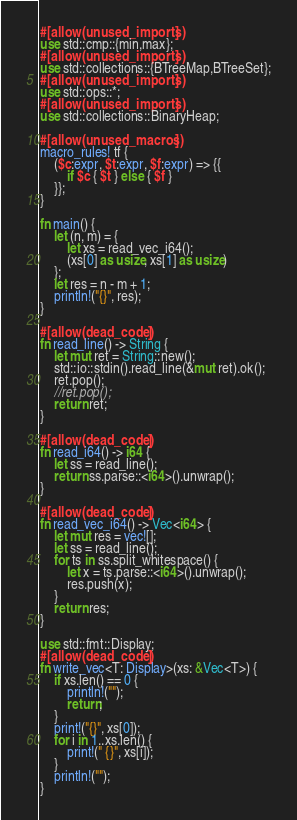<code> <loc_0><loc_0><loc_500><loc_500><_Rust_>#[allow(unused_imports)]
use std::cmp::{min,max};
#[allow(unused_imports)]
use std::collections::{BTreeMap,BTreeSet};
#[allow(unused_imports)]
use std::ops::*;
#[allow(unused_imports)]
use std::collections::BinaryHeap;

#[allow(unused_macros)]
macro_rules! tf {
    ($c:expr, $t:expr, $f:expr) => {{
        if $c { $t } else { $f }
    }};
}

fn main() {
    let (n, m) = {
        let xs = read_vec_i64();
        (xs[0] as usize, xs[1] as usize)
    };
    let res = n - m + 1;
    println!("{}", res);
}

#[allow(dead_code)]
fn read_line() -> String {
    let mut ret = String::new();
    std::io::stdin().read_line(&mut ret).ok();
    ret.pop();
    //ret.pop();
    return ret;
}

#[allow(dead_code)]
fn read_i64() -> i64 {
    let ss = read_line();
    return ss.parse::<i64>().unwrap();
}

#[allow(dead_code)]
fn read_vec_i64() -> Vec<i64> {
    let mut res = vec![];
    let ss = read_line();
    for ts in ss.split_whitespace() {
        let x = ts.parse::<i64>().unwrap();
        res.push(x);
    }
    return res;
}

use std::fmt::Display;
#[allow(dead_code)]
fn write_vec<T: Display>(xs: &Vec<T>) {
    if xs.len() == 0 {
        println!("");
        return;
    }
    print!("{}", xs[0]);
    for i in 1..xs.len() {
        print!(" {}", xs[i]);
    }
    println!("");
}
</code> 